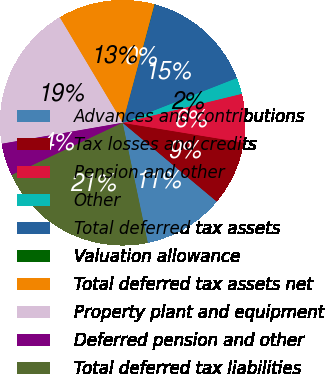Convert chart to OTSL. <chart><loc_0><loc_0><loc_500><loc_500><pie_chart><fcel>Advances and contributions<fcel>Tax losses and credits<fcel>Pension and other<fcel>Other<fcel>Total deferred tax assets<fcel>Valuation allowance<fcel>Total deferred tax assets net<fcel>Property plant and equipment<fcel>Deferred pension and other<fcel>Total deferred tax liabilities<nl><fcel>10.62%<fcel>8.5%<fcel>6.39%<fcel>2.15%<fcel>14.85%<fcel>0.03%<fcel>12.74%<fcel>19.17%<fcel>4.27%<fcel>21.28%<nl></chart> 